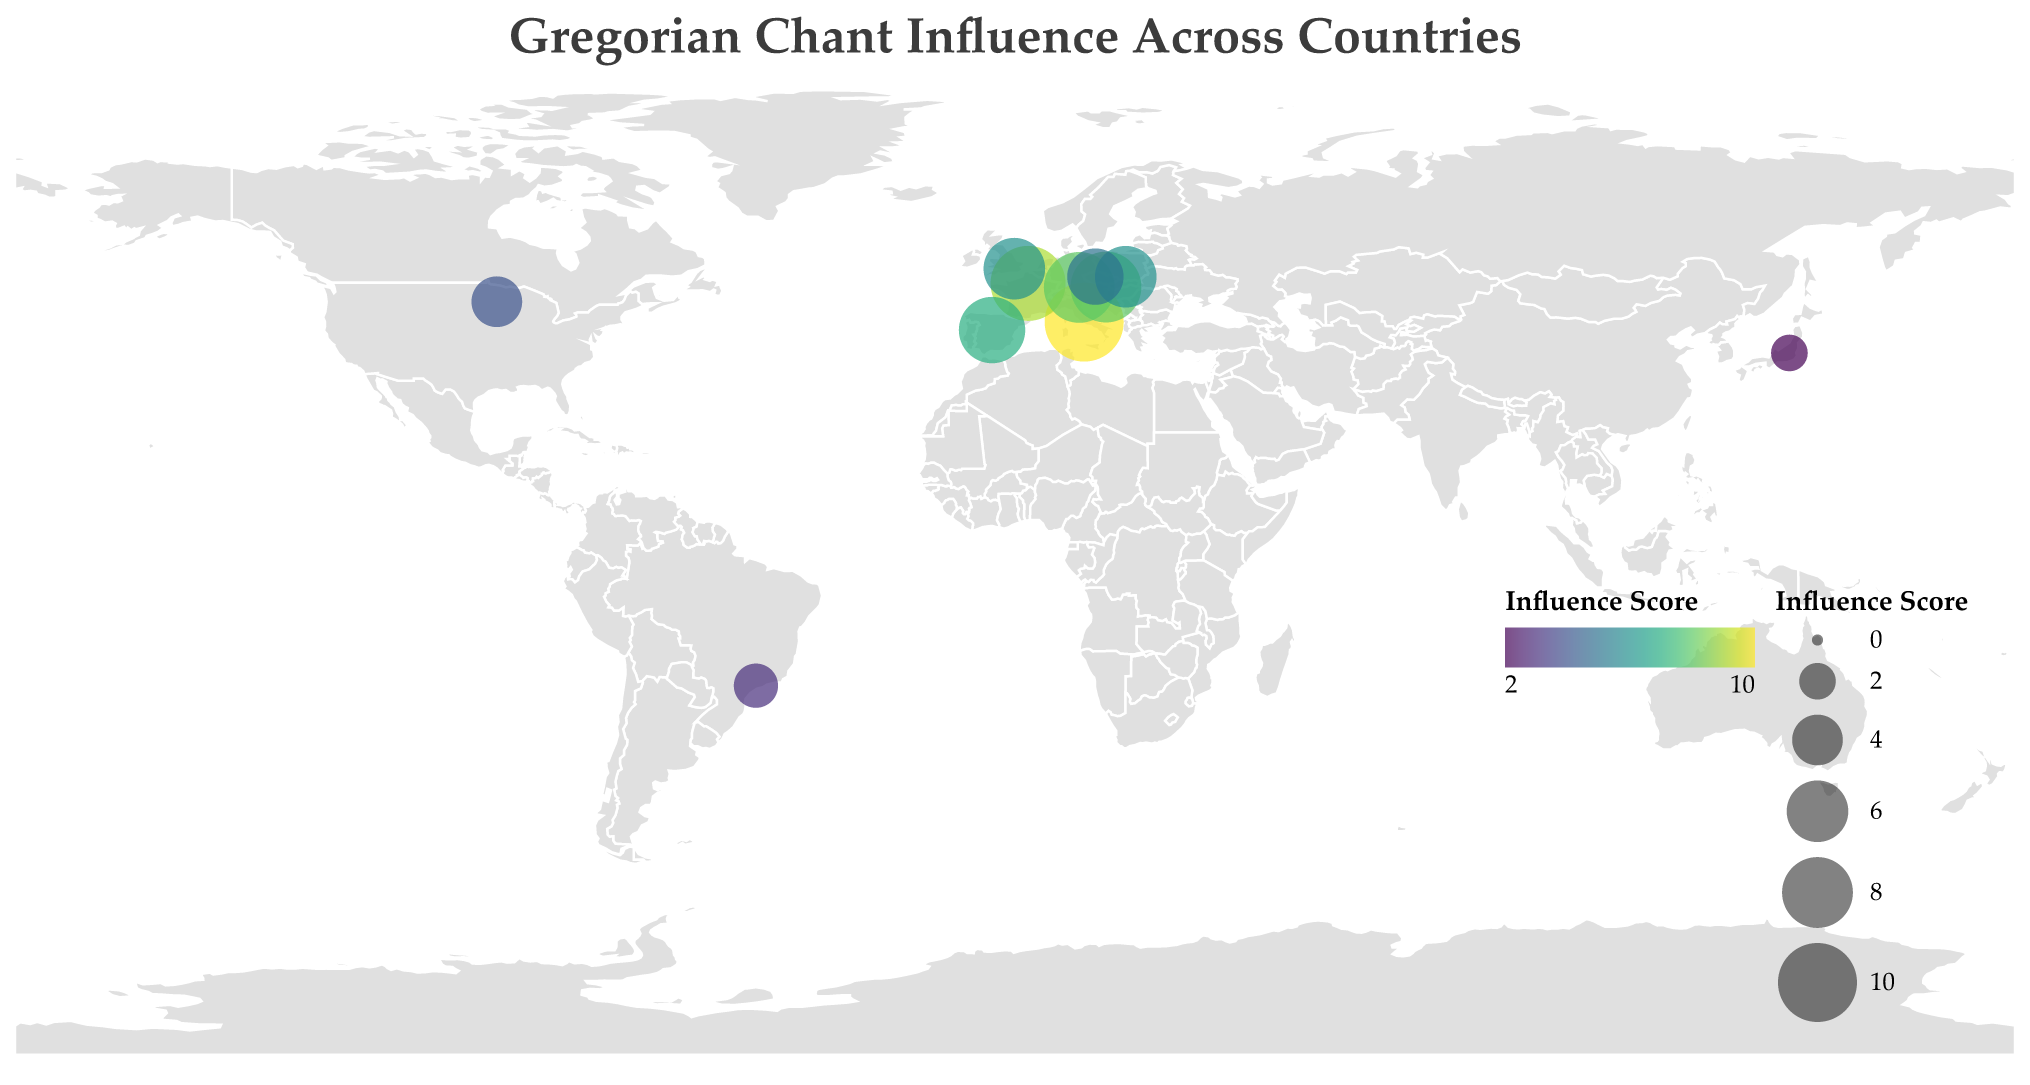What is the title of the figure? The title is usually prominently displayed at the top of the chart, providing a brief summary of what the chart is about. In this case, it is "Gregorian Chant Influence Across Countries".
Answer: Gregorian Chant Influence Across Countries Which country has the highest Gregorian Chant influence score? By observing the size and color of the circles corresponding to each country, we can identify that Italy has the largest and darkest circle, indicating the highest influence score of 10.
Answer: Italy What is the Gregorian Chant influence score for Saint John's Abbey in the United States? The influence score for each notable monastery is represented by the size of the circle. The circle corresponding to the United States (Minnesota) has an influence score of 4.
Answer: 4 How many countries have a Gregorian Chant influence score greater than or equal to 8? To answer this, count the number of circles with sizes indicating scores of 8 or above: Italy (10), France (9), Germany (8), and Austria (8). Thus, there are four such countries.
Answer: 4 Which regions in the figure have a Gregorian Chant influence score of 6? By checking the data, we find that Lesser Poland in Poland and England in the United Kingdom both have an influence score of 6.
Answer: Lesser Poland (Poland) and England (United Kingdom) Among the countries listed, which has the lowest Gregorian Chant influence score and what is the notable monastery there? The smallest and lightest circle in the figure represents the lowest influence score. This corresponds to the Trappist Monastery of Nasu in Japan, with a score of 2.
Answer: Japan, Trappist Monastery of Nasu Compare the Gregorian Chant influence score between Germany and Spain. Which country has a higher score? By examining the circles representing Germany and Spain, Germany has a score of 8, while Spain has a score of 7. Therefore, Germany has a higher score.
Answer: Germany What is the combined Gregorian Chant influence score for the countries in Europe listed in the plot? Sum the influence scores for the European countries: Italy (10), France (9), Germany (8), Spain (7), Austria (8), Poland (6), Czech Republic (5), and United Kingdom (6). The total is 10 + 9 + 8 + 7 + 8 + 6 + 5 + 6 = 59.
Answer: 59 Which two countries share the same Gregorian Chant influence score, and what is that score? By observing the sizes of the circles, Germany and Austria both have an influence score of 8.
Answer: Germany and Austria, 8 